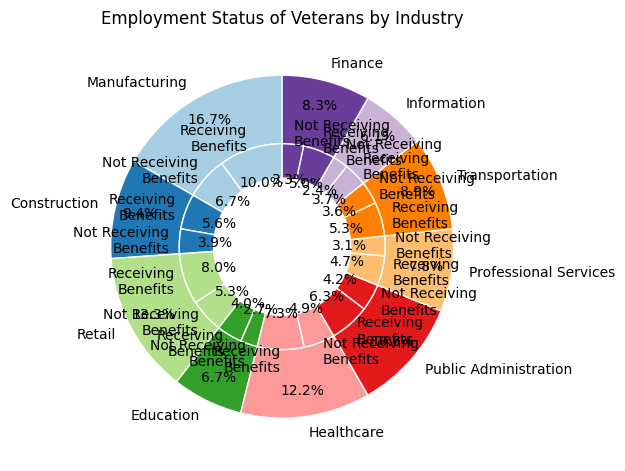Which industry has the highest percentage of veterans receiving healthcare benefits? By examining the outer slices of the chart, we see the percentage breakdowns for each industry. The exact values can be compared to identify the highest.
Answer: Manufacturing What is the difference in the number of veterans receiving healthcare benefits between the Construction and Healthcare industries? From the chart, we see the number of veterans receiving healthcare benefits in each industry. Subtract the number in Construction (50000) from Healthcare (66000).
Answer: 16000 Among the listed industries, which has a greater percentage of veterans not receiving healthcare benefits, Finance or Transportation? Check the inner pie chart slices labeled "Not Receiving Benefits" for both Finance and Transportation. Compare their relative proportions.
Answer: Finance What is the total number of veterans employed in both Education and Public Administration industries? Sum the total number of veterans employed in Education (60000) and Public Administration (95000).
Answer: 155000 Which industry has the smallest segment for veterans not receiving healthcare benefits? Look for the smallest inner pie slice labeled "Not Receiving Benefits".
Answer: Information In the Professional Services industry, what percentage of employed veterans are receiving healthcare benefits? Divide the number of veterans receiving healthcare benefits in Professional Services (42000) by the total employed in the same industry (70000), then multiply by 100 to get the percentage.
Answer: 60% Compare the total number of veterans employed in the Retail and Transportation industries. Which is higher? Compare the outer pie slices for Retail (120000) and Transportation (80000).
Answer: Retail What fraction of the total employed veterans in the Manufacturing industry are not receiving healthcare benefits? Divide the number of veterans not receiving healthcare benefits in Manufacturing (60000) by the total employed in Manufacturing (150000).
Answer: 0.4 Which industry shows an equal split between veterans receiving and not receiving healthcare benefits? Find an industry where the inner slices labeled "Receiving Benefits" and "Not Receiving Benefits" are equal.
Answer: None Among the industries listed, which one has the lowest total employment for veterans? Locate the smallest outer pie slice.
Answer: Information 